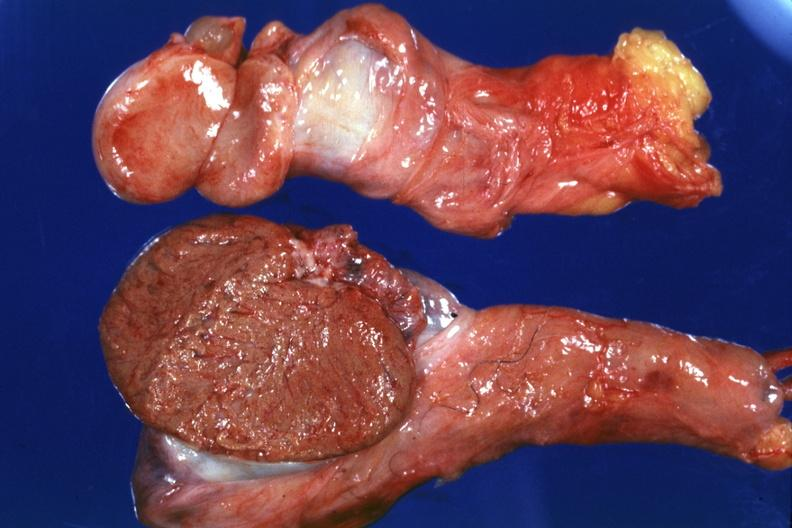do cut surface both testicles on normal and one quite small typical probably due to mumps have no history at this time?
Answer the question using a single word or phrase. Yes 